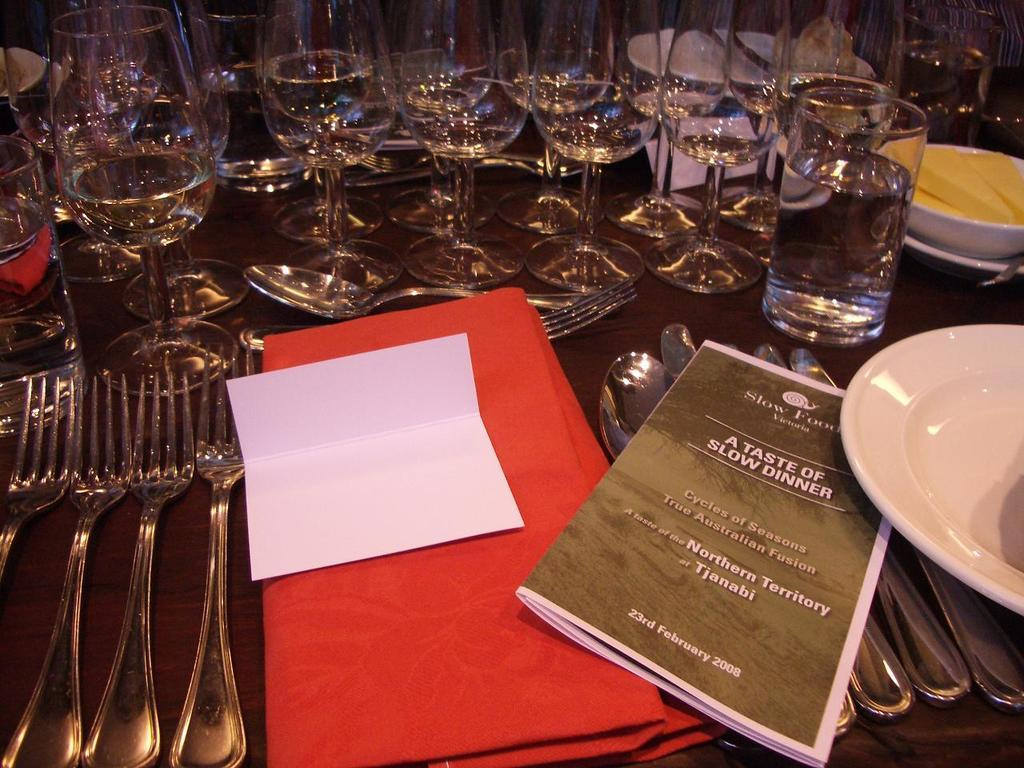What type of tableware can be seen on the table in the image? There are glasses, forks, and spoons on the table in the image. What color is the cloth on the table? The cloth on the table is red. Can you describe a dish item visible on the table? A part of a plate is visible on the table. What type of reading material is on the table? There is a magazine on the table. What type of government is depicted in the magazine on the table? The image does not show any depiction of a government in the magazine; it only shows the magazine itself. Is there a bat present on the table in the image? No, there is no bat visible on the table in the image. 